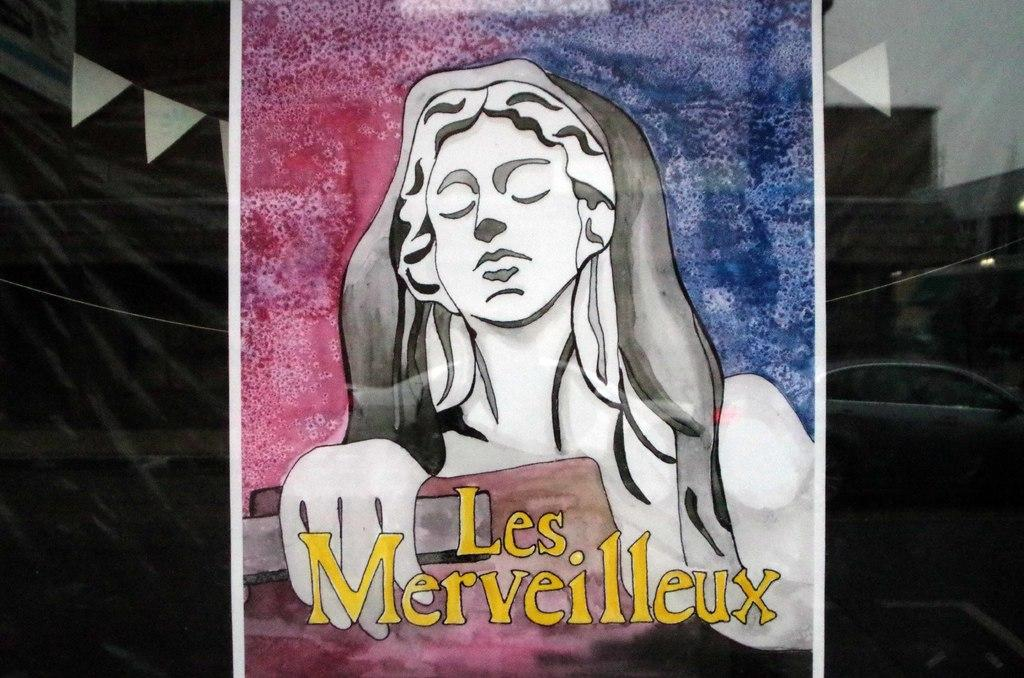What is depicted in the painting in the image? There is a painting of a woman in the image. Are there any words on the painting? Yes, the words "les merveilleux" are written on the painting. What can be seen behind the painting in the image? There is a black color curtain behind the painting. What is the title of the painting featuring your uncle in the image? There is no painting featuring an uncle in the image, and the title of the painting is not mentioned in the provided facts. 